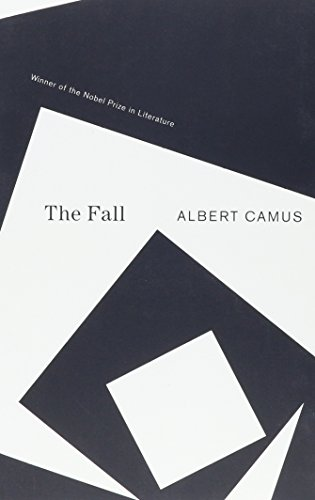Can you describe the significance of the artwork on the book cover of 'The Fall'? The artwork on the cover of 'The Fall' features abstract geometric shapes that might symbolize the complex layers and fragmentation in the narrative and the protagonist's psyche. 